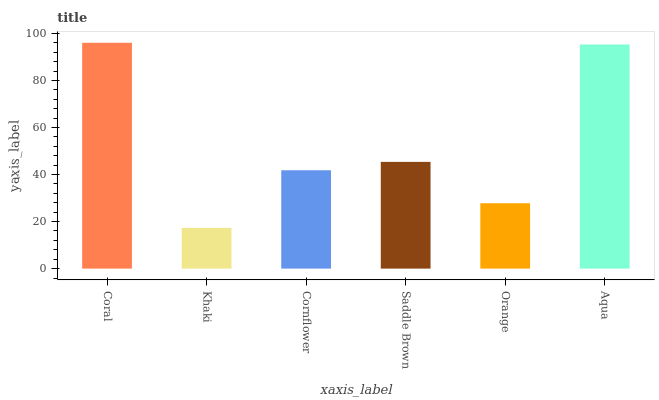Is Khaki the minimum?
Answer yes or no. Yes. Is Coral the maximum?
Answer yes or no. Yes. Is Cornflower the minimum?
Answer yes or no. No. Is Cornflower the maximum?
Answer yes or no. No. Is Cornflower greater than Khaki?
Answer yes or no. Yes. Is Khaki less than Cornflower?
Answer yes or no. Yes. Is Khaki greater than Cornflower?
Answer yes or no. No. Is Cornflower less than Khaki?
Answer yes or no. No. Is Saddle Brown the high median?
Answer yes or no. Yes. Is Cornflower the low median?
Answer yes or no. Yes. Is Khaki the high median?
Answer yes or no. No. Is Coral the low median?
Answer yes or no. No. 